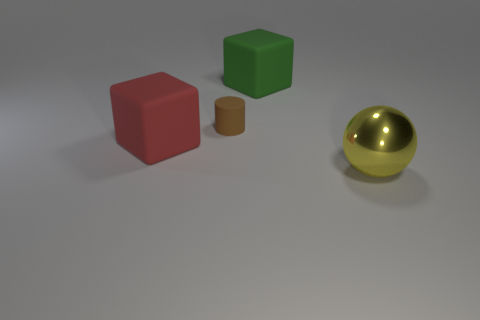Can you tell me the colors of the objects starting from the left? Certainly! From left to right, the objects are red, green, brown, and gold.  Which of these objects is reflective, and why might that be? The object on the far right, which is gold, is reflective. Its shiny surface suggests that it's likely made of a polished metal, designed to reflect light. 